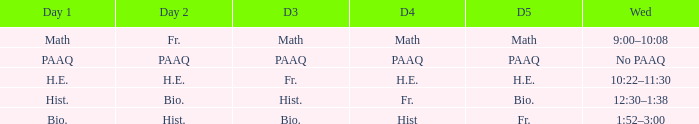What is the day 3 when day 4 is fr.? Hist. 